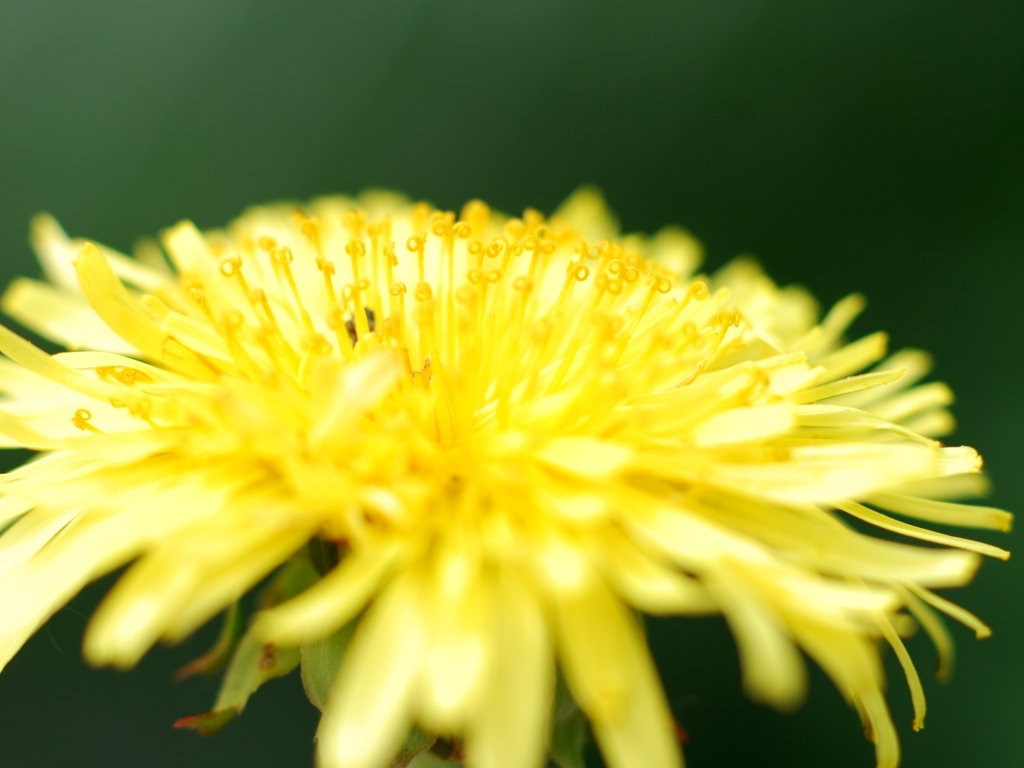Is the overall lighting of the image sufficient? The image has a soft lighting condition that highlights the intricate details of the flower's petals and the pollen grains. The background is uniformly blurred, which suggests a shallow depth of field and puts the focus solely on the flower. However, there are no harsh shadows or overly bright areas, indicating the lighting is well balanced for this type of close-up photography. 